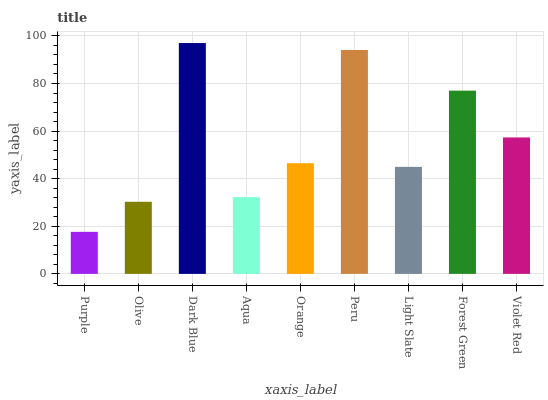Is Purple the minimum?
Answer yes or no. Yes. Is Dark Blue the maximum?
Answer yes or no. Yes. Is Olive the minimum?
Answer yes or no. No. Is Olive the maximum?
Answer yes or no. No. Is Olive greater than Purple?
Answer yes or no. Yes. Is Purple less than Olive?
Answer yes or no. Yes. Is Purple greater than Olive?
Answer yes or no. No. Is Olive less than Purple?
Answer yes or no. No. Is Orange the high median?
Answer yes or no. Yes. Is Orange the low median?
Answer yes or no. Yes. Is Violet Red the high median?
Answer yes or no. No. Is Light Slate the low median?
Answer yes or no. No. 